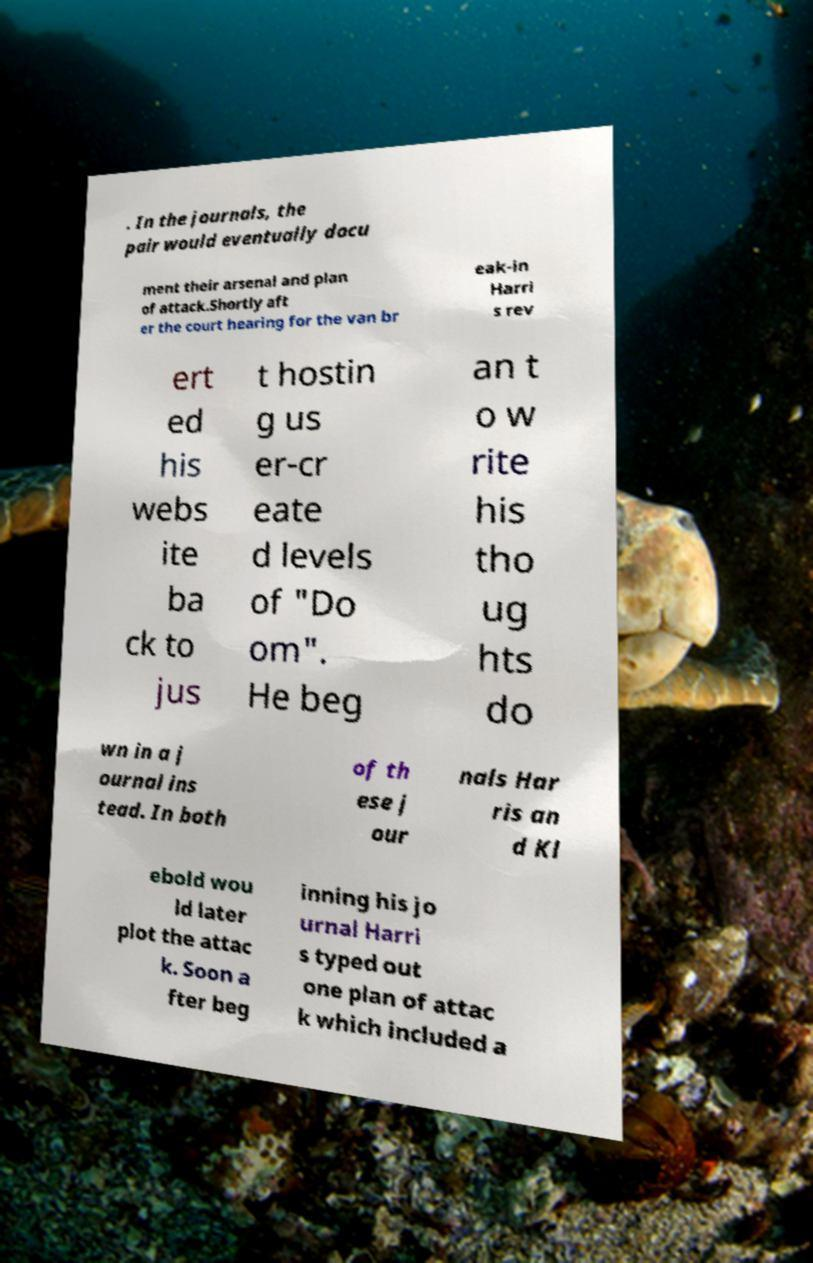Can you read and provide the text displayed in the image?This photo seems to have some interesting text. Can you extract and type it out for me? . In the journals, the pair would eventually docu ment their arsenal and plan of attack.Shortly aft er the court hearing for the van br eak-in Harri s rev ert ed his webs ite ba ck to jus t hostin g us er-cr eate d levels of "Do om". He beg an t o w rite his tho ug hts do wn in a j ournal ins tead. In both of th ese j our nals Har ris an d Kl ebold wou ld later plot the attac k. Soon a fter beg inning his jo urnal Harri s typed out one plan of attac k which included a 